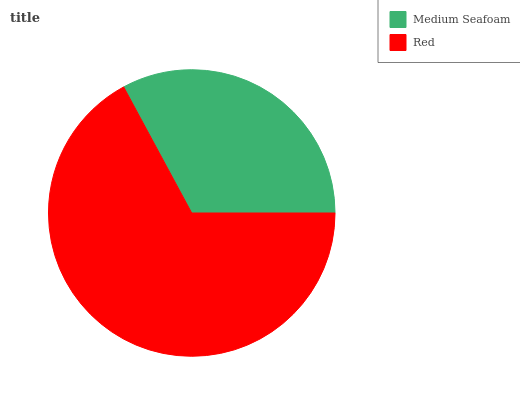Is Medium Seafoam the minimum?
Answer yes or no. Yes. Is Red the maximum?
Answer yes or no. Yes. Is Red the minimum?
Answer yes or no. No. Is Red greater than Medium Seafoam?
Answer yes or no. Yes. Is Medium Seafoam less than Red?
Answer yes or no. Yes. Is Medium Seafoam greater than Red?
Answer yes or no. No. Is Red less than Medium Seafoam?
Answer yes or no. No. Is Red the high median?
Answer yes or no. Yes. Is Medium Seafoam the low median?
Answer yes or no. Yes. Is Medium Seafoam the high median?
Answer yes or no. No. Is Red the low median?
Answer yes or no. No. 